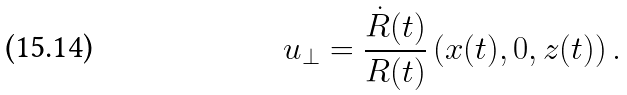<formula> <loc_0><loc_0><loc_500><loc_500>u _ { \perp } = \frac { \dot { R } ( t ) } { R ( t ) } \left ( x ( t ) , 0 , z ( t ) \right ) .</formula> 